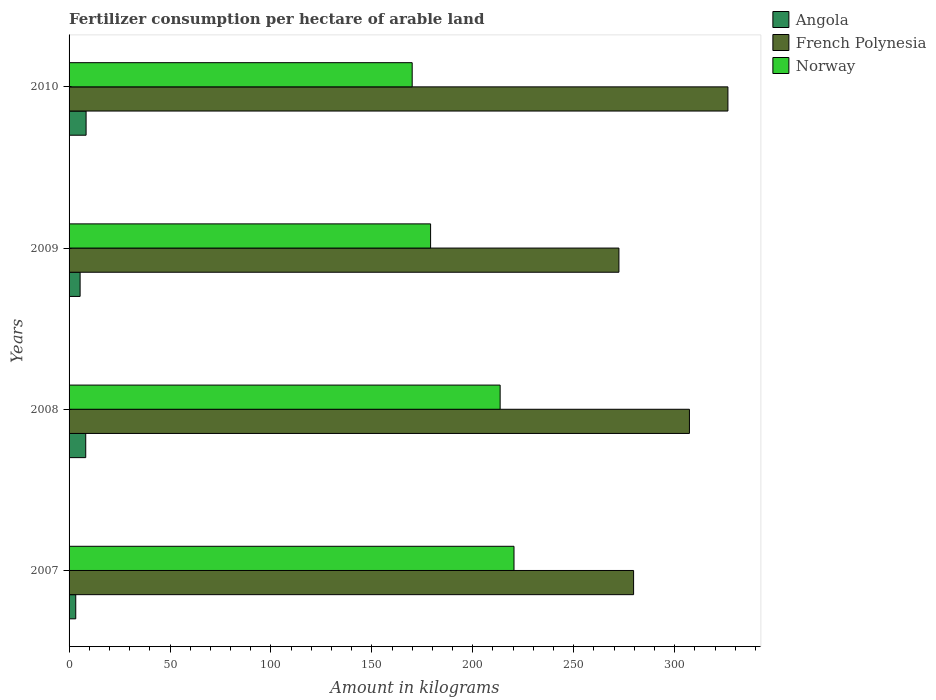How many groups of bars are there?
Offer a terse response. 4. Are the number of bars on each tick of the Y-axis equal?
Your answer should be compact. Yes. How many bars are there on the 1st tick from the bottom?
Keep it short and to the point. 3. In how many cases, is the number of bars for a given year not equal to the number of legend labels?
Keep it short and to the point. 0. What is the amount of fertilizer consumption in Norway in 2008?
Ensure brevity in your answer.  213.56. Across all years, what is the maximum amount of fertilizer consumption in French Polynesia?
Give a very brief answer. 326.4. Across all years, what is the minimum amount of fertilizer consumption in Norway?
Make the answer very short. 169.98. In which year was the amount of fertilizer consumption in French Polynesia maximum?
Your response must be concise. 2010. In which year was the amount of fertilizer consumption in Norway minimum?
Your answer should be very brief. 2010. What is the total amount of fertilizer consumption in French Polynesia in the graph?
Give a very brief answer. 1185.8. What is the difference between the amount of fertilizer consumption in French Polynesia in 2008 and that in 2009?
Provide a succinct answer. 34.93. What is the difference between the amount of fertilizer consumption in Norway in 2010 and the amount of fertilizer consumption in Angola in 2009?
Ensure brevity in your answer.  164.51. What is the average amount of fertilizer consumption in Norway per year?
Offer a very short reply. 195.76. In the year 2007, what is the difference between the amount of fertilizer consumption in Angola and amount of fertilizer consumption in French Polynesia?
Keep it short and to the point. -276.36. What is the ratio of the amount of fertilizer consumption in Angola in 2008 to that in 2010?
Offer a very short reply. 0.98. Is the difference between the amount of fertilizer consumption in Angola in 2008 and 2010 greater than the difference between the amount of fertilizer consumption in French Polynesia in 2008 and 2010?
Provide a short and direct response. Yes. What is the difference between the highest and the second highest amount of fertilizer consumption in Angola?
Your answer should be compact. 0.17. What is the difference between the highest and the lowest amount of fertilizer consumption in Norway?
Offer a terse response. 50.43. In how many years, is the amount of fertilizer consumption in Angola greater than the average amount of fertilizer consumption in Angola taken over all years?
Your answer should be compact. 2. What does the 2nd bar from the top in 2010 represents?
Ensure brevity in your answer.  French Polynesia. What does the 2nd bar from the bottom in 2010 represents?
Ensure brevity in your answer.  French Polynesia. Is it the case that in every year, the sum of the amount of fertilizer consumption in French Polynesia and amount of fertilizer consumption in Norway is greater than the amount of fertilizer consumption in Angola?
Make the answer very short. Yes. How many bars are there?
Your response must be concise. 12. Are the values on the major ticks of X-axis written in scientific E-notation?
Your response must be concise. No. Where does the legend appear in the graph?
Offer a very short reply. Top right. How many legend labels are there?
Your response must be concise. 3. What is the title of the graph?
Your answer should be compact. Fertilizer consumption per hectare of arable land. What is the label or title of the X-axis?
Your answer should be very brief. Amount in kilograms. What is the Amount in kilograms of Angola in 2007?
Your answer should be very brief. 3.31. What is the Amount in kilograms in French Polynesia in 2007?
Provide a short and direct response. 279.67. What is the Amount in kilograms in Norway in 2007?
Your response must be concise. 220.42. What is the Amount in kilograms of Angola in 2008?
Your answer should be compact. 8.26. What is the Amount in kilograms of French Polynesia in 2008?
Keep it short and to the point. 307.33. What is the Amount in kilograms of Norway in 2008?
Keep it short and to the point. 213.56. What is the Amount in kilograms in Angola in 2009?
Offer a terse response. 5.47. What is the Amount in kilograms in French Polynesia in 2009?
Keep it short and to the point. 272.4. What is the Amount in kilograms of Norway in 2009?
Keep it short and to the point. 179.1. What is the Amount in kilograms of Angola in 2010?
Offer a terse response. 8.43. What is the Amount in kilograms of French Polynesia in 2010?
Provide a short and direct response. 326.4. What is the Amount in kilograms in Norway in 2010?
Offer a terse response. 169.98. Across all years, what is the maximum Amount in kilograms in Angola?
Your response must be concise. 8.43. Across all years, what is the maximum Amount in kilograms of French Polynesia?
Keep it short and to the point. 326.4. Across all years, what is the maximum Amount in kilograms of Norway?
Keep it short and to the point. 220.42. Across all years, what is the minimum Amount in kilograms in Angola?
Make the answer very short. 3.31. Across all years, what is the minimum Amount in kilograms of French Polynesia?
Your answer should be compact. 272.4. Across all years, what is the minimum Amount in kilograms in Norway?
Offer a very short reply. 169.98. What is the total Amount in kilograms of Angola in the graph?
Give a very brief answer. 25.47. What is the total Amount in kilograms in French Polynesia in the graph?
Ensure brevity in your answer.  1185.8. What is the total Amount in kilograms in Norway in the graph?
Make the answer very short. 783.06. What is the difference between the Amount in kilograms in Angola in 2007 and that in 2008?
Provide a short and direct response. -4.95. What is the difference between the Amount in kilograms of French Polynesia in 2007 and that in 2008?
Offer a very short reply. -27.67. What is the difference between the Amount in kilograms of Norway in 2007 and that in 2008?
Offer a terse response. 6.86. What is the difference between the Amount in kilograms in Angola in 2007 and that in 2009?
Your answer should be compact. -2.17. What is the difference between the Amount in kilograms of French Polynesia in 2007 and that in 2009?
Give a very brief answer. 7.27. What is the difference between the Amount in kilograms in Norway in 2007 and that in 2009?
Provide a succinct answer. 41.32. What is the difference between the Amount in kilograms in Angola in 2007 and that in 2010?
Provide a succinct answer. -5.12. What is the difference between the Amount in kilograms of French Polynesia in 2007 and that in 2010?
Your response must be concise. -46.73. What is the difference between the Amount in kilograms of Norway in 2007 and that in 2010?
Make the answer very short. 50.43. What is the difference between the Amount in kilograms of Angola in 2008 and that in 2009?
Give a very brief answer. 2.79. What is the difference between the Amount in kilograms of French Polynesia in 2008 and that in 2009?
Your answer should be very brief. 34.93. What is the difference between the Amount in kilograms of Norway in 2008 and that in 2009?
Keep it short and to the point. 34.46. What is the difference between the Amount in kilograms in Angola in 2008 and that in 2010?
Ensure brevity in your answer.  -0.17. What is the difference between the Amount in kilograms in French Polynesia in 2008 and that in 2010?
Provide a succinct answer. -19.07. What is the difference between the Amount in kilograms in Norway in 2008 and that in 2010?
Provide a short and direct response. 43.57. What is the difference between the Amount in kilograms of Angola in 2009 and that in 2010?
Your answer should be very brief. -2.96. What is the difference between the Amount in kilograms of French Polynesia in 2009 and that in 2010?
Provide a succinct answer. -54. What is the difference between the Amount in kilograms in Norway in 2009 and that in 2010?
Make the answer very short. 9.12. What is the difference between the Amount in kilograms in Angola in 2007 and the Amount in kilograms in French Polynesia in 2008?
Offer a very short reply. -304.03. What is the difference between the Amount in kilograms of Angola in 2007 and the Amount in kilograms of Norway in 2008?
Ensure brevity in your answer.  -210.25. What is the difference between the Amount in kilograms in French Polynesia in 2007 and the Amount in kilograms in Norway in 2008?
Your answer should be compact. 66.11. What is the difference between the Amount in kilograms of Angola in 2007 and the Amount in kilograms of French Polynesia in 2009?
Your answer should be compact. -269.1. What is the difference between the Amount in kilograms in Angola in 2007 and the Amount in kilograms in Norway in 2009?
Provide a succinct answer. -175.79. What is the difference between the Amount in kilograms in French Polynesia in 2007 and the Amount in kilograms in Norway in 2009?
Give a very brief answer. 100.57. What is the difference between the Amount in kilograms of Angola in 2007 and the Amount in kilograms of French Polynesia in 2010?
Keep it short and to the point. -323.1. What is the difference between the Amount in kilograms in Angola in 2007 and the Amount in kilograms in Norway in 2010?
Your answer should be very brief. -166.68. What is the difference between the Amount in kilograms of French Polynesia in 2007 and the Amount in kilograms of Norway in 2010?
Your answer should be compact. 109.68. What is the difference between the Amount in kilograms in Angola in 2008 and the Amount in kilograms in French Polynesia in 2009?
Your response must be concise. -264.14. What is the difference between the Amount in kilograms in Angola in 2008 and the Amount in kilograms in Norway in 2009?
Make the answer very short. -170.84. What is the difference between the Amount in kilograms of French Polynesia in 2008 and the Amount in kilograms of Norway in 2009?
Provide a short and direct response. 128.23. What is the difference between the Amount in kilograms of Angola in 2008 and the Amount in kilograms of French Polynesia in 2010?
Ensure brevity in your answer.  -318.14. What is the difference between the Amount in kilograms in Angola in 2008 and the Amount in kilograms in Norway in 2010?
Provide a short and direct response. -161.72. What is the difference between the Amount in kilograms of French Polynesia in 2008 and the Amount in kilograms of Norway in 2010?
Offer a very short reply. 137.35. What is the difference between the Amount in kilograms in Angola in 2009 and the Amount in kilograms in French Polynesia in 2010?
Your response must be concise. -320.93. What is the difference between the Amount in kilograms in Angola in 2009 and the Amount in kilograms in Norway in 2010?
Keep it short and to the point. -164.51. What is the difference between the Amount in kilograms of French Polynesia in 2009 and the Amount in kilograms of Norway in 2010?
Make the answer very short. 102.42. What is the average Amount in kilograms in Angola per year?
Provide a short and direct response. 6.37. What is the average Amount in kilograms in French Polynesia per year?
Make the answer very short. 296.45. What is the average Amount in kilograms of Norway per year?
Keep it short and to the point. 195.76. In the year 2007, what is the difference between the Amount in kilograms of Angola and Amount in kilograms of French Polynesia?
Keep it short and to the point. -276.36. In the year 2007, what is the difference between the Amount in kilograms of Angola and Amount in kilograms of Norway?
Your response must be concise. -217.11. In the year 2007, what is the difference between the Amount in kilograms of French Polynesia and Amount in kilograms of Norway?
Make the answer very short. 59.25. In the year 2008, what is the difference between the Amount in kilograms of Angola and Amount in kilograms of French Polynesia?
Ensure brevity in your answer.  -299.07. In the year 2008, what is the difference between the Amount in kilograms of Angola and Amount in kilograms of Norway?
Your answer should be compact. -205.3. In the year 2008, what is the difference between the Amount in kilograms in French Polynesia and Amount in kilograms in Norway?
Your response must be concise. 93.78. In the year 2009, what is the difference between the Amount in kilograms of Angola and Amount in kilograms of French Polynesia?
Offer a terse response. -266.93. In the year 2009, what is the difference between the Amount in kilograms in Angola and Amount in kilograms in Norway?
Your answer should be very brief. -173.63. In the year 2009, what is the difference between the Amount in kilograms in French Polynesia and Amount in kilograms in Norway?
Give a very brief answer. 93.3. In the year 2010, what is the difference between the Amount in kilograms of Angola and Amount in kilograms of French Polynesia?
Keep it short and to the point. -317.97. In the year 2010, what is the difference between the Amount in kilograms of Angola and Amount in kilograms of Norway?
Make the answer very short. -161.55. In the year 2010, what is the difference between the Amount in kilograms in French Polynesia and Amount in kilograms in Norway?
Ensure brevity in your answer.  156.42. What is the ratio of the Amount in kilograms in Angola in 2007 to that in 2008?
Provide a short and direct response. 0.4. What is the ratio of the Amount in kilograms of French Polynesia in 2007 to that in 2008?
Make the answer very short. 0.91. What is the ratio of the Amount in kilograms in Norway in 2007 to that in 2008?
Offer a very short reply. 1.03. What is the ratio of the Amount in kilograms in Angola in 2007 to that in 2009?
Give a very brief answer. 0.6. What is the ratio of the Amount in kilograms in French Polynesia in 2007 to that in 2009?
Ensure brevity in your answer.  1.03. What is the ratio of the Amount in kilograms in Norway in 2007 to that in 2009?
Provide a succinct answer. 1.23. What is the ratio of the Amount in kilograms of Angola in 2007 to that in 2010?
Your response must be concise. 0.39. What is the ratio of the Amount in kilograms in French Polynesia in 2007 to that in 2010?
Your response must be concise. 0.86. What is the ratio of the Amount in kilograms in Norway in 2007 to that in 2010?
Your answer should be very brief. 1.3. What is the ratio of the Amount in kilograms of Angola in 2008 to that in 2009?
Provide a succinct answer. 1.51. What is the ratio of the Amount in kilograms of French Polynesia in 2008 to that in 2009?
Your answer should be compact. 1.13. What is the ratio of the Amount in kilograms in Norway in 2008 to that in 2009?
Your answer should be compact. 1.19. What is the ratio of the Amount in kilograms of Angola in 2008 to that in 2010?
Offer a terse response. 0.98. What is the ratio of the Amount in kilograms of French Polynesia in 2008 to that in 2010?
Keep it short and to the point. 0.94. What is the ratio of the Amount in kilograms of Norway in 2008 to that in 2010?
Provide a succinct answer. 1.26. What is the ratio of the Amount in kilograms in Angola in 2009 to that in 2010?
Provide a short and direct response. 0.65. What is the ratio of the Amount in kilograms of French Polynesia in 2009 to that in 2010?
Offer a terse response. 0.83. What is the ratio of the Amount in kilograms in Norway in 2009 to that in 2010?
Give a very brief answer. 1.05. What is the difference between the highest and the second highest Amount in kilograms in Angola?
Ensure brevity in your answer.  0.17. What is the difference between the highest and the second highest Amount in kilograms of French Polynesia?
Your response must be concise. 19.07. What is the difference between the highest and the second highest Amount in kilograms of Norway?
Offer a terse response. 6.86. What is the difference between the highest and the lowest Amount in kilograms of Angola?
Offer a very short reply. 5.12. What is the difference between the highest and the lowest Amount in kilograms in Norway?
Give a very brief answer. 50.43. 